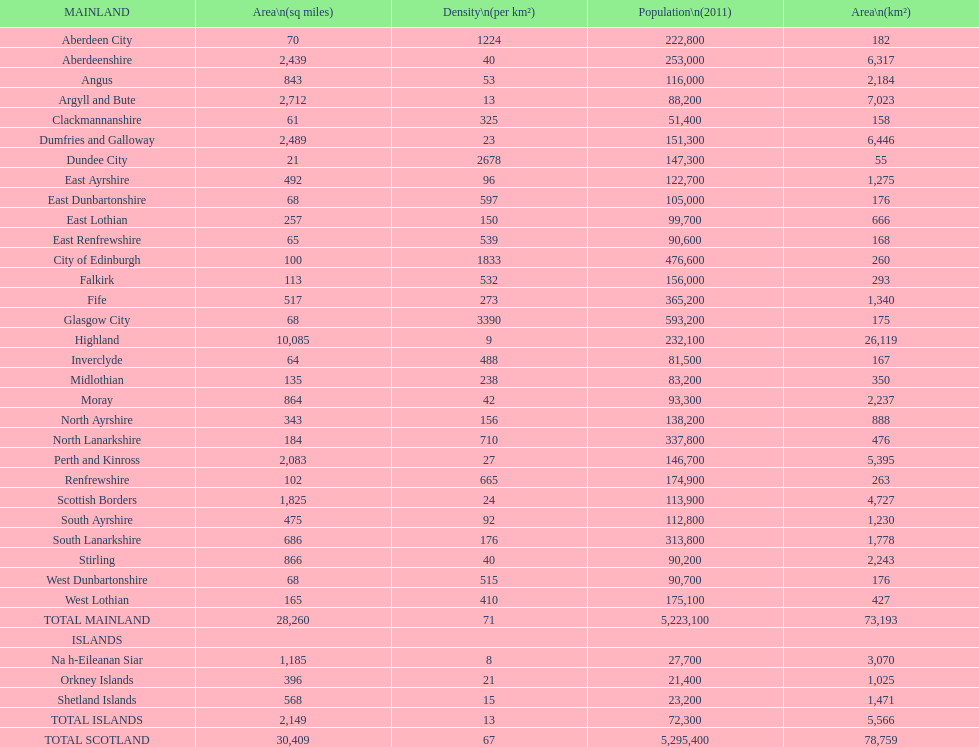What is the number of people living in angus in 2011? 116,000. I'm looking to parse the entire table for insights. Could you assist me with that? {'header': ['MAINLAND', 'Area\\n(sq miles)', 'Density\\n(per km²)', 'Population\\n(2011)', 'Area\\n(km²)'], 'rows': [['Aberdeen City', '70', '1224', '222,800', '182'], ['Aberdeenshire', '2,439', '40', '253,000', '6,317'], ['Angus', '843', '53', '116,000', '2,184'], ['Argyll and Bute', '2,712', '13', '88,200', '7,023'], ['Clackmannanshire', '61', '325', '51,400', '158'], ['Dumfries and Galloway', '2,489', '23', '151,300', '6,446'], ['Dundee City', '21', '2678', '147,300', '55'], ['East Ayrshire', '492', '96', '122,700', '1,275'], ['East Dunbartonshire', '68', '597', '105,000', '176'], ['East Lothian', '257', '150', '99,700', '666'], ['East Renfrewshire', '65', '539', '90,600', '168'], ['City of Edinburgh', '100', '1833', '476,600', '260'], ['Falkirk', '113', '532', '156,000', '293'], ['Fife', '517', '273', '365,200', '1,340'], ['Glasgow City', '68', '3390', '593,200', '175'], ['Highland', '10,085', '9', '232,100', '26,119'], ['Inverclyde', '64', '488', '81,500', '167'], ['Midlothian', '135', '238', '83,200', '350'], ['Moray', '864', '42', '93,300', '2,237'], ['North Ayrshire', '343', '156', '138,200', '888'], ['North Lanarkshire', '184', '710', '337,800', '476'], ['Perth and Kinross', '2,083', '27', '146,700', '5,395'], ['Renfrewshire', '102', '665', '174,900', '263'], ['Scottish Borders', '1,825', '24', '113,900', '4,727'], ['South Ayrshire', '475', '92', '112,800', '1,230'], ['South Lanarkshire', '686', '176', '313,800', '1,778'], ['Stirling', '866', '40', '90,200', '2,243'], ['West Dunbartonshire', '68', '515', '90,700', '176'], ['West Lothian', '165', '410', '175,100', '427'], ['TOTAL MAINLAND', '28,260', '71', '5,223,100', '73,193'], ['ISLANDS', '', '', '', ''], ['Na h-Eileanan Siar', '1,185', '8', '27,700', '3,070'], ['Orkney Islands', '396', '21', '21,400', '1,025'], ['Shetland Islands', '568', '15', '23,200', '1,471'], ['TOTAL ISLANDS', '2,149', '13', '72,300', '5,566'], ['TOTAL SCOTLAND', '30,409', '67', '5,295,400', '78,759']]} 